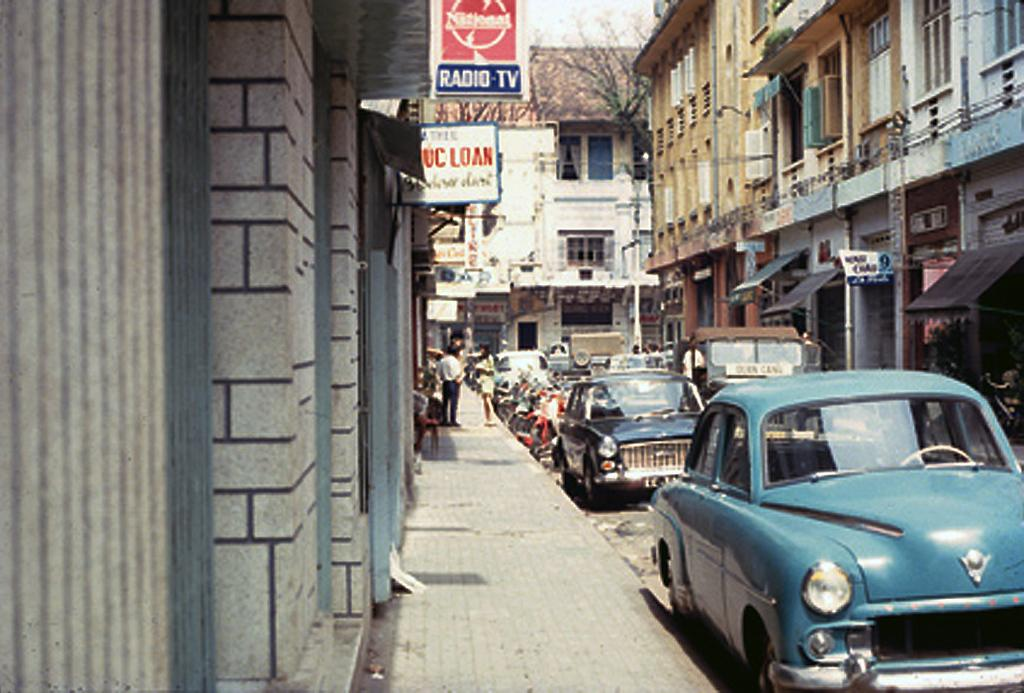What type of structures can be seen in the image? There are buildings in the image. What feature is visible on the buildings? There are windows visible in the image. What type of vegetation is present in the image? Dry trees are present in the image. What objects can be seen in the image that are used for displaying information or advertisements? There are boards in the image. Who or what is present in the image? There are people in the image. What type of establishments can be seen in the image? Stores are visible in the image. What part of the natural environment is visible in the image? The sky is visible in the image. What mode of transportation can be seen on the road in the image? There are vehicles on the road in the image. Can you tell me how many frogs are swimming in the river in the image? There is no river or frogs present in the image. What type of ocean creatures can be seen in the image? There are no ocean creatures present in the image. 